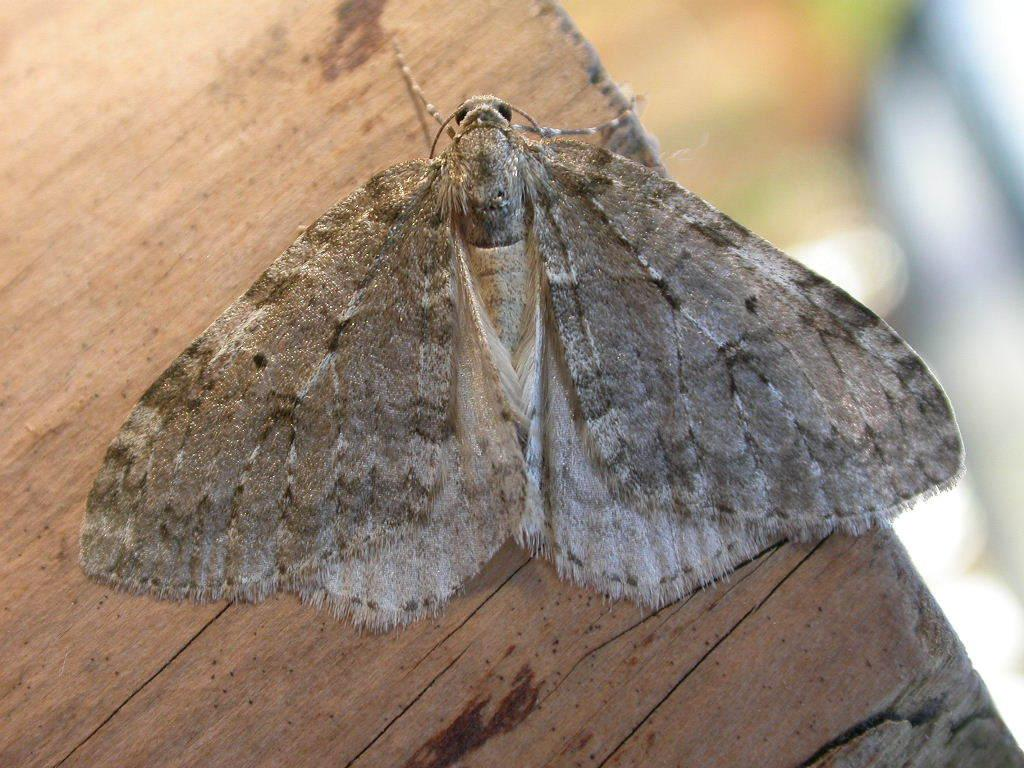What is the main subject of the image? There is a butterfly in the image. What type of surface is the butterfly on? The butterfly is on a wooden surface. What grade did the mother receive from the men in the image? There is no mother, men, or grade present in the image; it only features a butterfly on a wooden surface. 